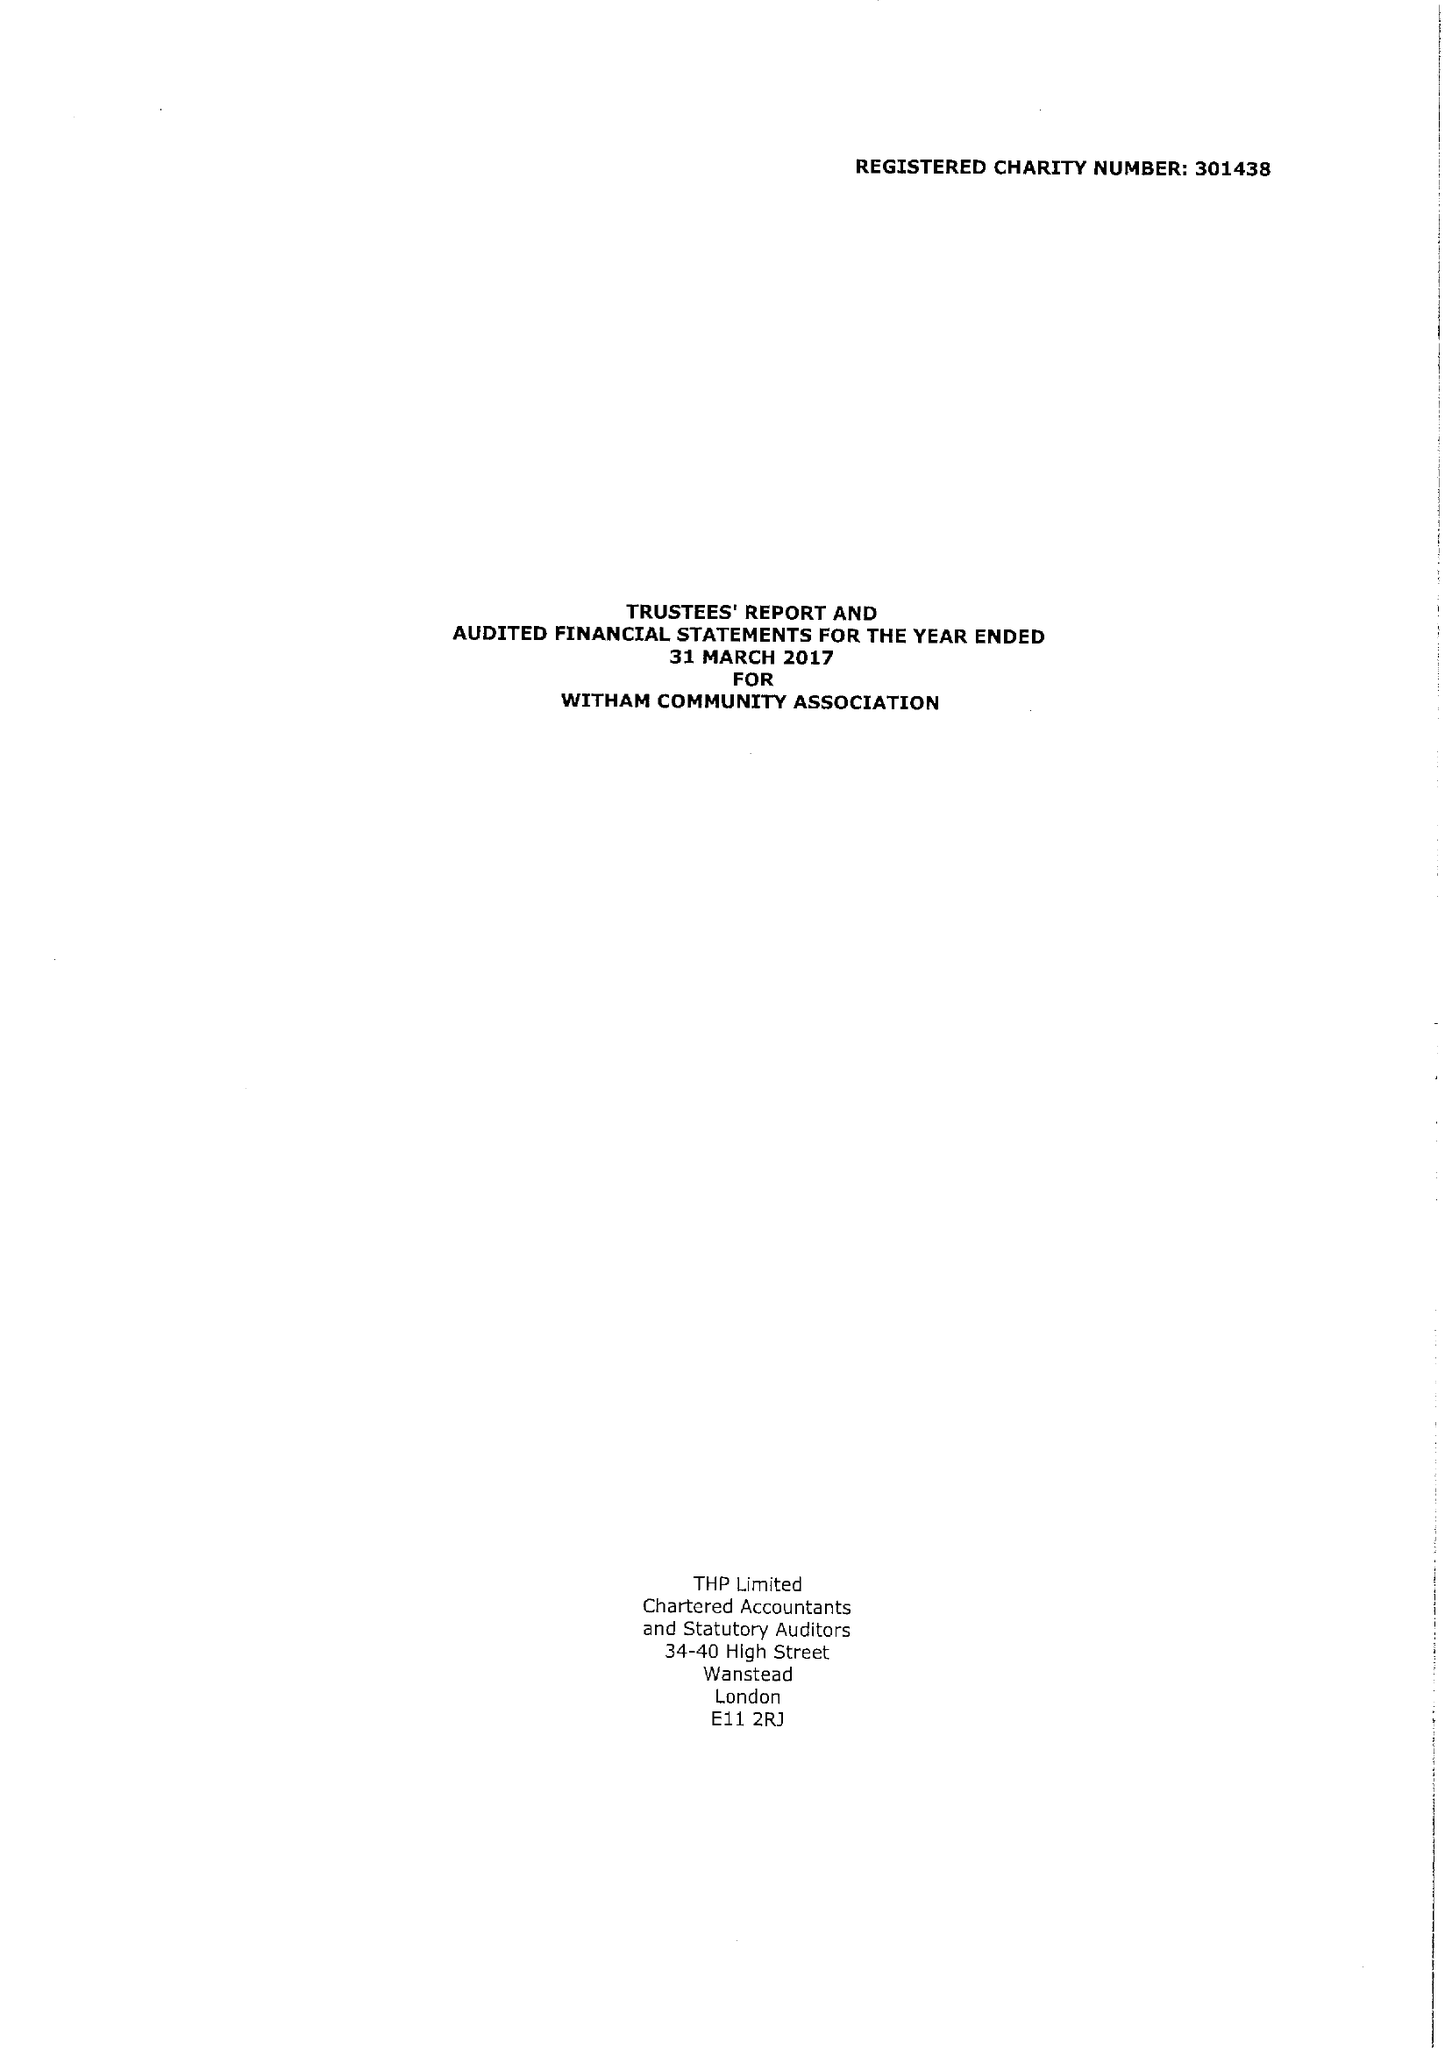What is the value for the spending_annually_in_british_pounds?
Answer the question using a single word or phrase. 182672.00 